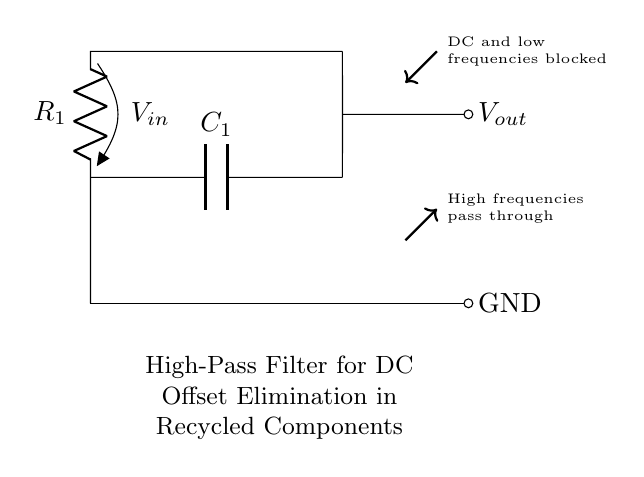What type of filter is this circuit? The circuit is labeled as a high-pass filter, which is indicated in the description provided in the circuit diagram.
Answer: High-pass filter What components are used in this circuit? The key components present in the circuit are a resistor and a capacitor. The resistor is denoted as R1, and the capacitor is denoted as C1.
Answer: Resistor, Capacitor What voltage is applied to the input? The input voltage is indicated as V_in, which shows the voltage that will be subjected to the filter action through the resistor R1.
Answer: V_in What happens to DC and low frequencies in this filter? The diagram states that DC and low frequencies are blocked, which indicates that this filter is designed to prevent these signals from passing through to the output.
Answer: Blocked What is the output of the circuit? The output voltage (V_out) is connected to the junction after the capacitor, allowing high frequencies from the input to pass while blocking low frequencies.
Answer: V_out What role does the capacitor play in this circuit? The capacitor (C1) serves to block DC while allowing AC signals (high frequencies) to pass through, thus performing the high-pass function of the filter.
Answer: Block DC What type of signal does this filter allow to pass? The filter allows high frequencies to pass through, which is explicitly stated in the diagram notes indicating that high frequencies pass while DC and low frequencies do not.
Answer: High frequencies 